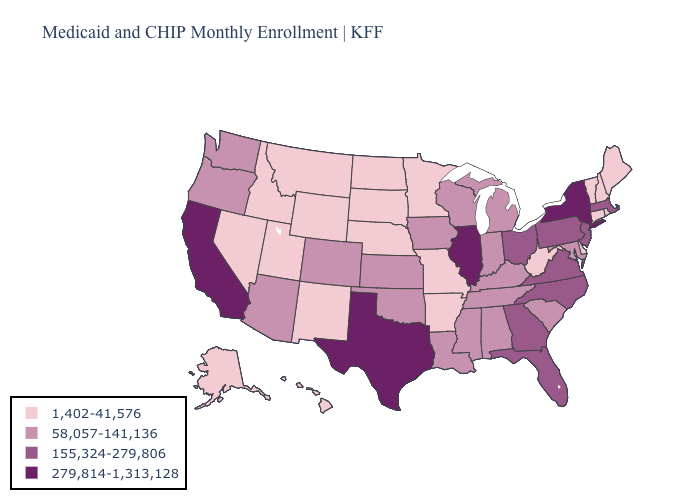Among the states that border Arizona , which have the highest value?
Write a very short answer. California. Which states hav the highest value in the MidWest?
Concise answer only. Illinois. Does New York have the highest value in the Northeast?
Be succinct. Yes. What is the lowest value in the USA?
Quick response, please. 1,402-41,576. What is the value of Kansas?
Be succinct. 58,057-141,136. Does Arizona have the highest value in the West?
Write a very short answer. No. What is the lowest value in states that border Texas?
Write a very short answer. 1,402-41,576. What is the highest value in the South ?
Concise answer only. 279,814-1,313,128. What is the highest value in states that border Pennsylvania?
Give a very brief answer. 279,814-1,313,128. Name the states that have a value in the range 58,057-141,136?
Write a very short answer. Alabama, Arizona, Colorado, Indiana, Iowa, Kansas, Kentucky, Louisiana, Maryland, Michigan, Mississippi, Oklahoma, Oregon, South Carolina, Tennessee, Washington, Wisconsin. What is the highest value in states that border Vermont?
Write a very short answer. 279,814-1,313,128. Name the states that have a value in the range 155,324-279,806?
Keep it brief. Florida, Georgia, Massachusetts, New Jersey, North Carolina, Ohio, Pennsylvania, Virginia. What is the lowest value in the USA?
Keep it brief. 1,402-41,576. Does the first symbol in the legend represent the smallest category?
Give a very brief answer. Yes. Does Mississippi have a higher value than Nevada?
Short answer required. Yes. 